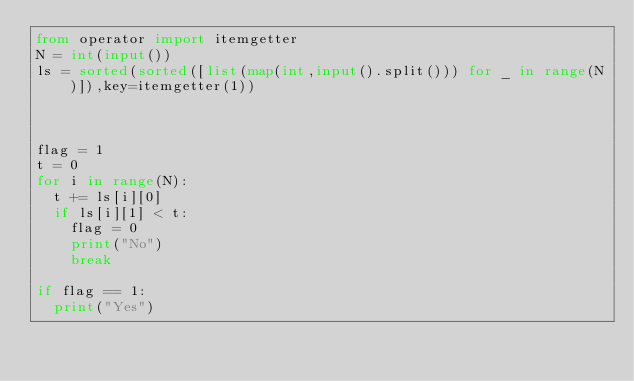<code> <loc_0><loc_0><loc_500><loc_500><_Python_>from operator import itemgetter
N = int(input())
ls = sorted(sorted([list(map(int,input().split())) for _ in range(N)]),key=itemgetter(1))



flag = 1
t = 0
for i in range(N):
  t += ls[i][0]
  if ls[i][1] < t:
    flag = 0
    print("No")
    break

if flag == 1:
  print("Yes")</code> 